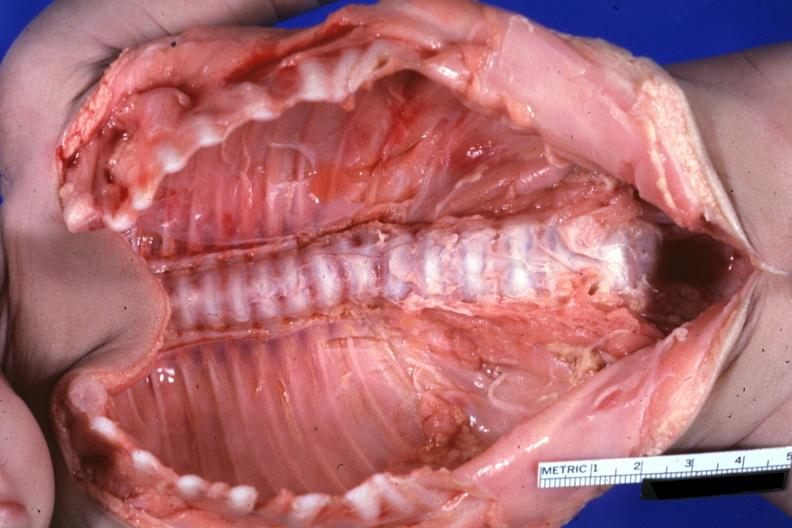s joints present?
Answer the question using a single word or phrase. Yes 